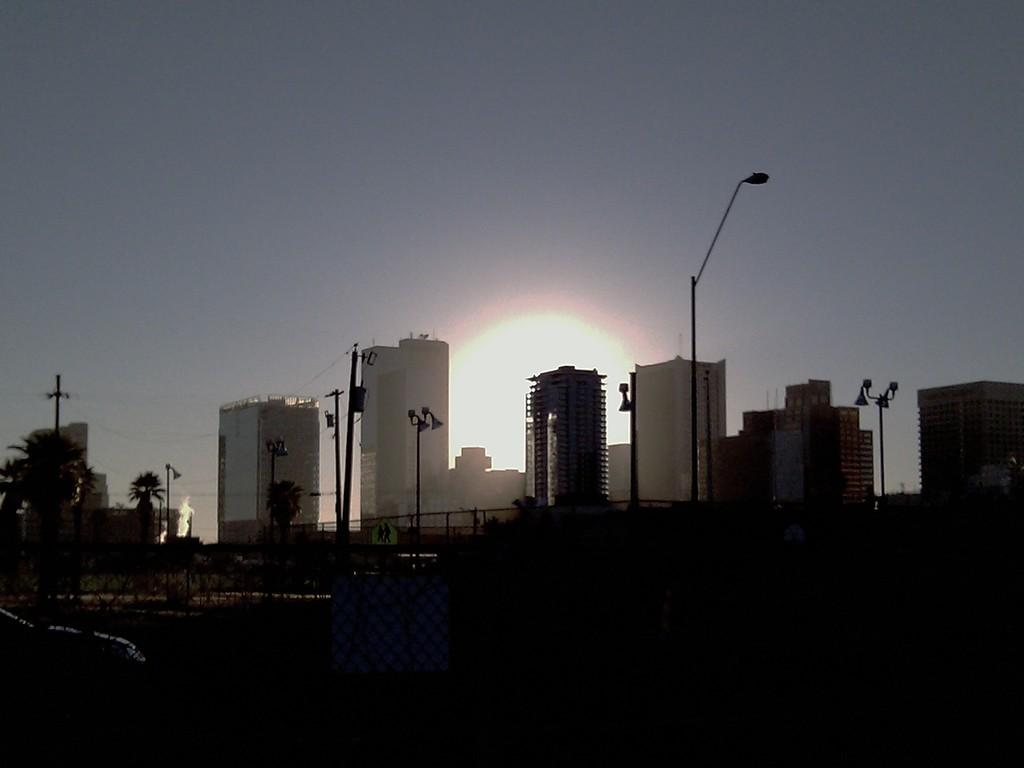What type of natural elements can be seen in the image? There are trees in the image. What man-made structures are present in the image? There are poles and buildings in the image. What part of the natural environment is visible in the image? The sky is visible in the background of the image. How would you describe the lighting at the bottom of the image? The bottom of the image appears to be dark. What story is being told by the cushion in the image? There is no cushion present in the image, so no story can be told by it. Can you hear the voice of the trees in the image? Trees do not have voices, so it is not possible to hear their voice in the image. 